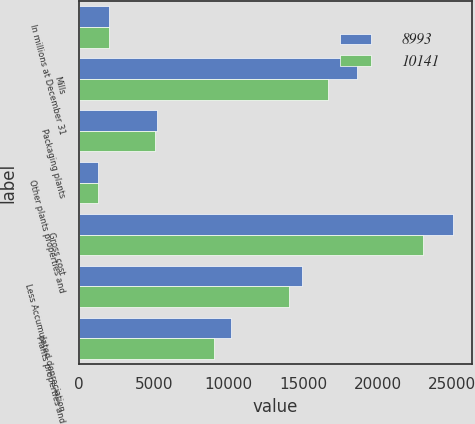<chart> <loc_0><loc_0><loc_500><loc_500><stacked_bar_chart><ecel><fcel>In millions at December 31<fcel>Mills<fcel>Packaging plants<fcel>Other plants properties and<fcel>Gross cost<fcel>Less Accumulated depreciation<fcel>Plants properties and<nl><fcel>8993<fcel>2007<fcel>18579<fcel>5205<fcel>1262<fcel>25046<fcel>14905<fcel>10141<nl><fcel>10141<fcel>2006<fcel>16665<fcel>5093<fcel>1285<fcel>23043<fcel>14050<fcel>8993<nl></chart> 